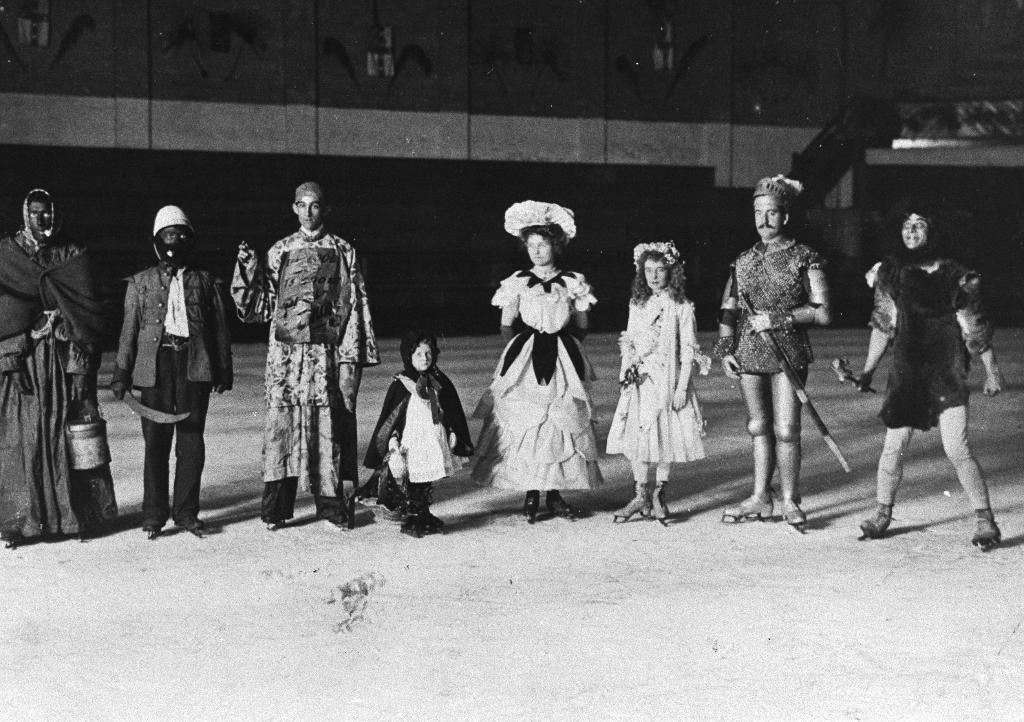How many people are in the image? There is a group of persons in the image. What are the persons in the image doing? The persons are standing on the ground. What can be seen in the background of the image? There is a wall in the background of the image. What language are the persons speaking in the image? The provided facts do not mention any language spoken by the persons in the image. What noise can be heard coming from the persons in the image? The provided facts do not mention any noise made by the persons in the image. 